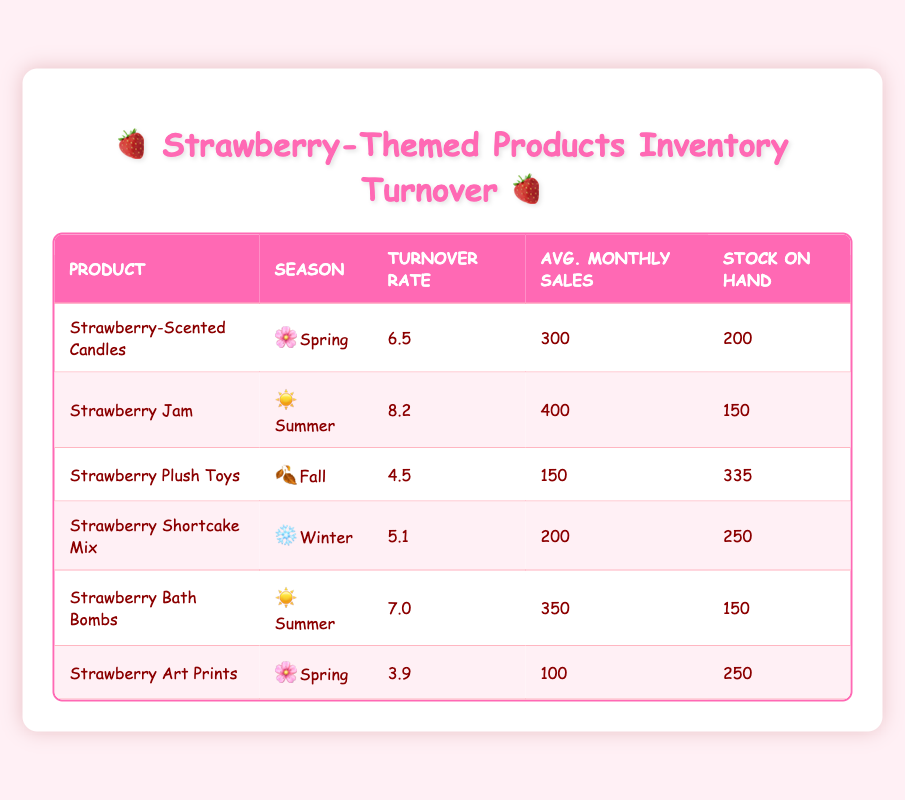What is the turnover rate for Strawberry Shortcake Mix? The turnover rate for Strawberry Shortcake Mix is specified in the table under the corresponding product row. It shows a value of 5.1.
Answer: 5.1 Which product has the highest average monthly sales? To find which product has the highest average monthly sales, we can compare the values under the "Avg. Monthly Sales" column. Strawberry Jam has the highest value at 400.
Answer: Strawberry Jam Is the turnover rate for Strawberry-Scented Candles higher than that for Strawberry Plush Toys? By comparing the turnover rates, Strawberry-Scented Candles have a turnover rate of 6.5, while Strawberry Plush Toys have a rate of 4.5. Therefore, yes, the rate for Strawberry-Scented Candles is higher.
Answer: Yes What is the combined turnover rate of all products in the Summer season? We need to look at the turnover rates specifically in the Summer season, which includes Strawberry Jam at 8.2 and Strawberry Bath Bombs at 7.0. Adding these gives 8.2 + 7.0 = 15.2.
Answer: 15.2 Are there more Strawberry Plush Toys in stock than Strawberry Bath Bombs? The stock on hand for Strawberry Plush Toys is 335, while for Strawberry Bath Bombs, it is 150. Since 335 is greater than 150, the statement is true.
Answer: Yes What is the average turnover rate for all products sold in Spring? For Spring products, the turnover rates are 6.5 (Strawberry-Scented Candles) and 3.9 (Strawberry Art Prints). Adding them gives 6.5 + 3.9 = 10.4. To find the average, we divide by the number of products, which is 2: 10.4 / 2 = 5.2.
Answer: 5.2 Which season has the lowest average monthly sales across its products? We identify the seasons and their respective products: Spring (300 & 100), Summer (400 & 350), Fall (150), and Winter (200). The average monthly sales for Spring is (300 + 100) / 2 = 200; Summer is (400 + 350) / 2 = 375; Fall is 150; Winter is 200. The lowest is for Fall at 150.
Answer: Fall 